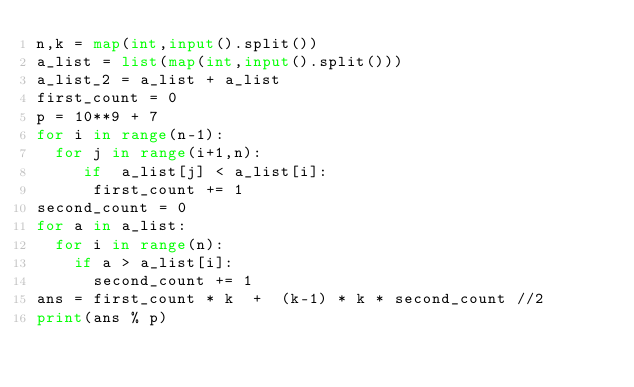<code> <loc_0><loc_0><loc_500><loc_500><_Python_>n,k = map(int,input().split())
a_list = list(map(int,input().split()))
a_list_2 = a_list + a_list
first_count = 0
p = 10**9 + 7
for i in range(n-1):
  for j in range(i+1,n):
     if  a_list[j] < a_list[i]:
      first_count += 1
second_count = 0    
for a in a_list:
  for i in range(n):
    if a > a_list[i]:
      second_count += 1
ans = first_count * k  +  (k-1) * k * second_count //2
print(ans % p)
    

  
</code> 